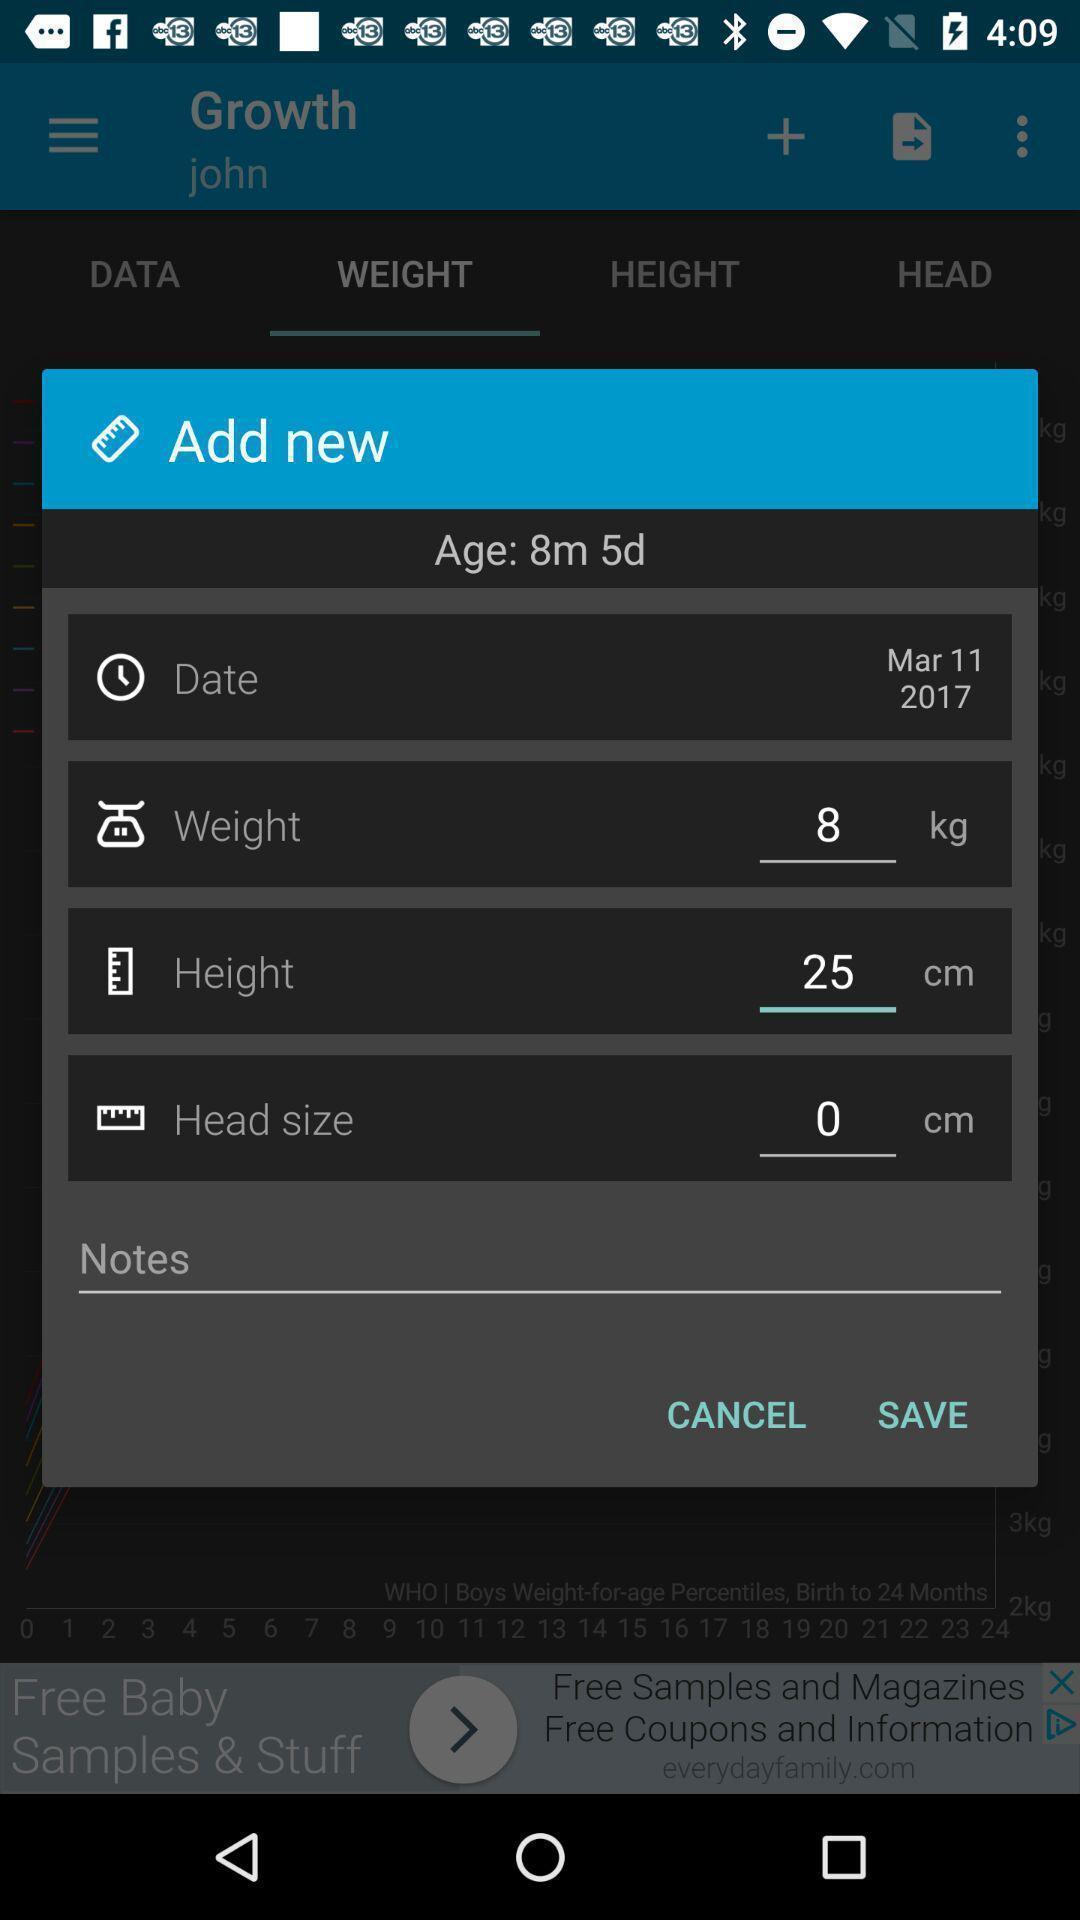Explain the elements present in this screenshot. Popup to add new options in the baby tracker app. 